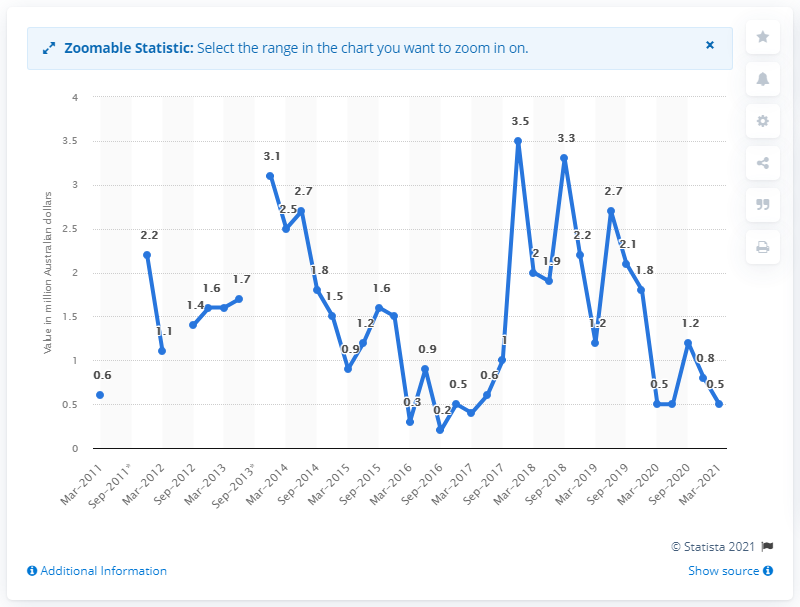Highlight a few significant elements in this photo. In March 2021, approximately 0.5 million Australian dollars was spent on diamond exploration in Australia. 